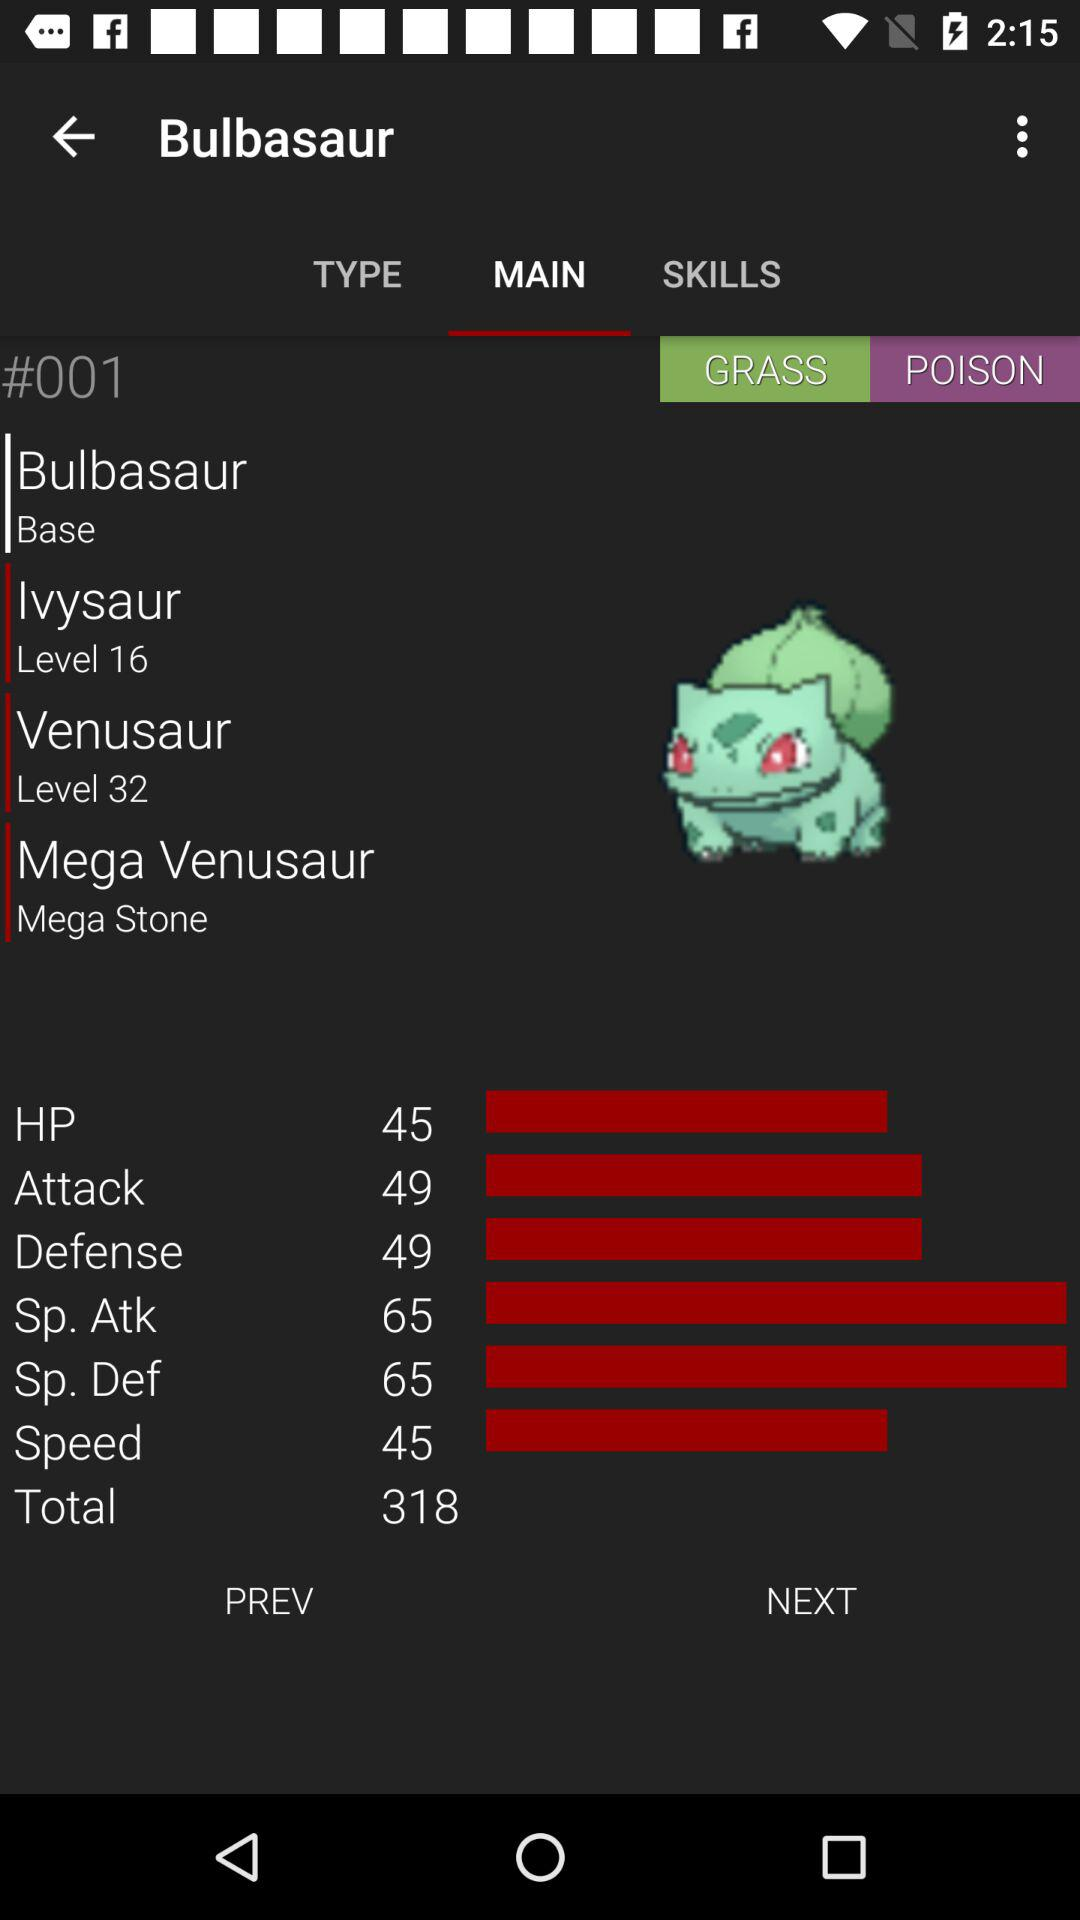What is the score for the attack? The score for the attack is 49. 